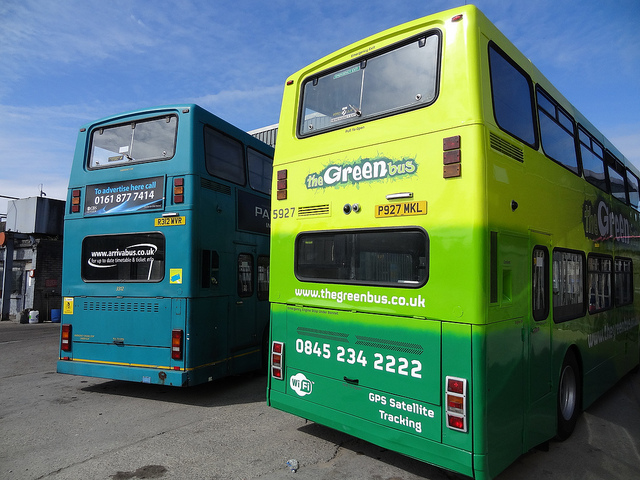Please extract the text content from this image. Green www.thegreenbus.co.uk 2222 5927 7414 GREEN PA bus the P927MKL call here advertise To R312 WVR 877 0161 Tracking Satellite GPS Fi Wi 234 0845 